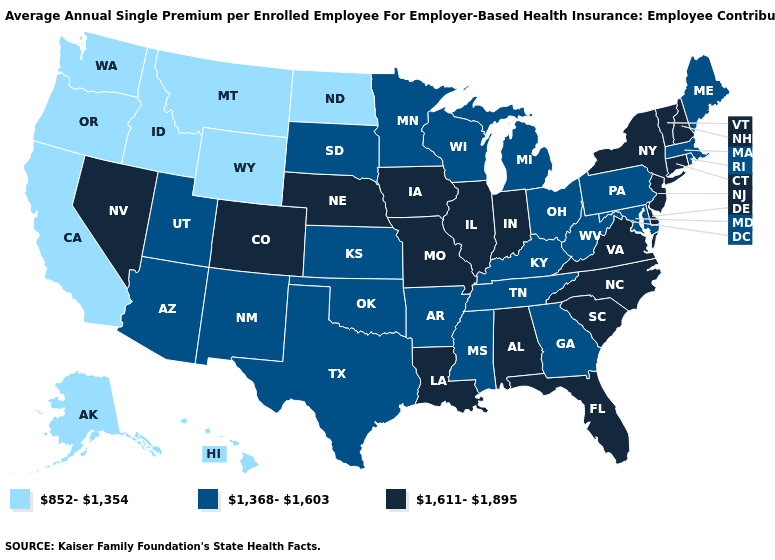Which states have the lowest value in the Northeast?
Write a very short answer. Maine, Massachusetts, Pennsylvania, Rhode Island. Which states have the lowest value in the MidWest?
Quick response, please. North Dakota. Among the states that border Ohio , does Indiana have the lowest value?
Concise answer only. No. What is the value of New Jersey?
Short answer required. 1,611-1,895. Which states have the lowest value in the South?
Short answer required. Arkansas, Georgia, Kentucky, Maryland, Mississippi, Oklahoma, Tennessee, Texas, West Virginia. What is the highest value in the USA?
Write a very short answer. 1,611-1,895. What is the value of Maryland?
Write a very short answer. 1,368-1,603. Does New Jersey have the same value as Washington?
Answer briefly. No. What is the highest value in the USA?
Keep it brief. 1,611-1,895. What is the value of Michigan?
Concise answer only. 1,368-1,603. What is the value of Connecticut?
Concise answer only. 1,611-1,895. Among the states that border Nevada , which have the lowest value?
Concise answer only. California, Idaho, Oregon. Does Minnesota have the lowest value in the MidWest?
Write a very short answer. No. Which states have the highest value in the USA?
Short answer required. Alabama, Colorado, Connecticut, Delaware, Florida, Illinois, Indiana, Iowa, Louisiana, Missouri, Nebraska, Nevada, New Hampshire, New Jersey, New York, North Carolina, South Carolina, Vermont, Virginia. Does Missouri have the highest value in the MidWest?
Short answer required. Yes. 